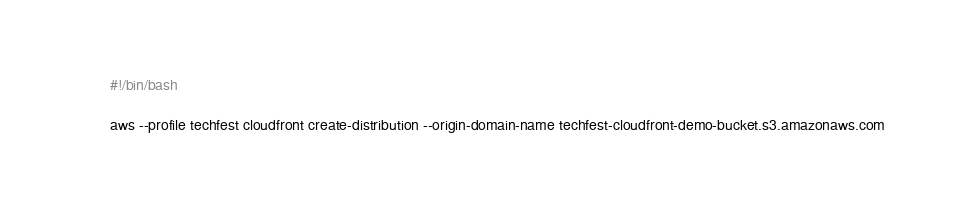<code> <loc_0><loc_0><loc_500><loc_500><_Bash_>#!/bin/bash

aws --profile techfest cloudfront create-distribution --origin-domain-name techfest-cloudfront-demo-bucket.s3.amazonaws.com
</code> 